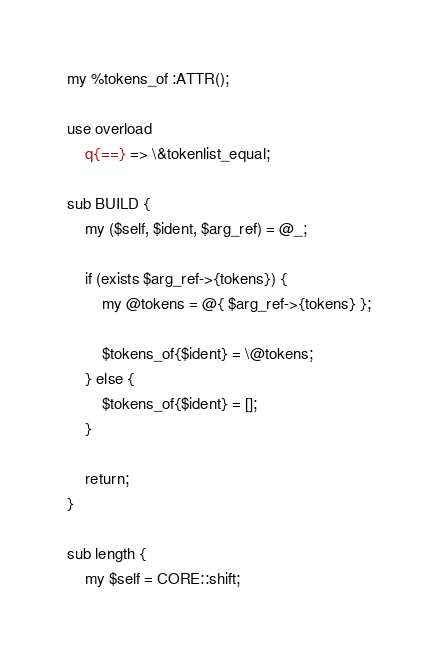<code> <loc_0><loc_0><loc_500><loc_500><_Perl_>
my %tokens_of :ATTR();

use overload
    q{==} => \&tokenlist_equal;

sub BUILD {
    my ($self, $ident, $arg_ref) = @_;

    if (exists $arg_ref->{tokens}) {
        my @tokens = @{ $arg_ref->{tokens} };

        $tokens_of{$ident} = \@tokens;
    } else {
        $tokens_of{$ident} = [];
    }

    return;
}

sub length {
    my $self = CORE::shift;
</code> 